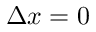<formula> <loc_0><loc_0><loc_500><loc_500>\Delta x = 0</formula> 